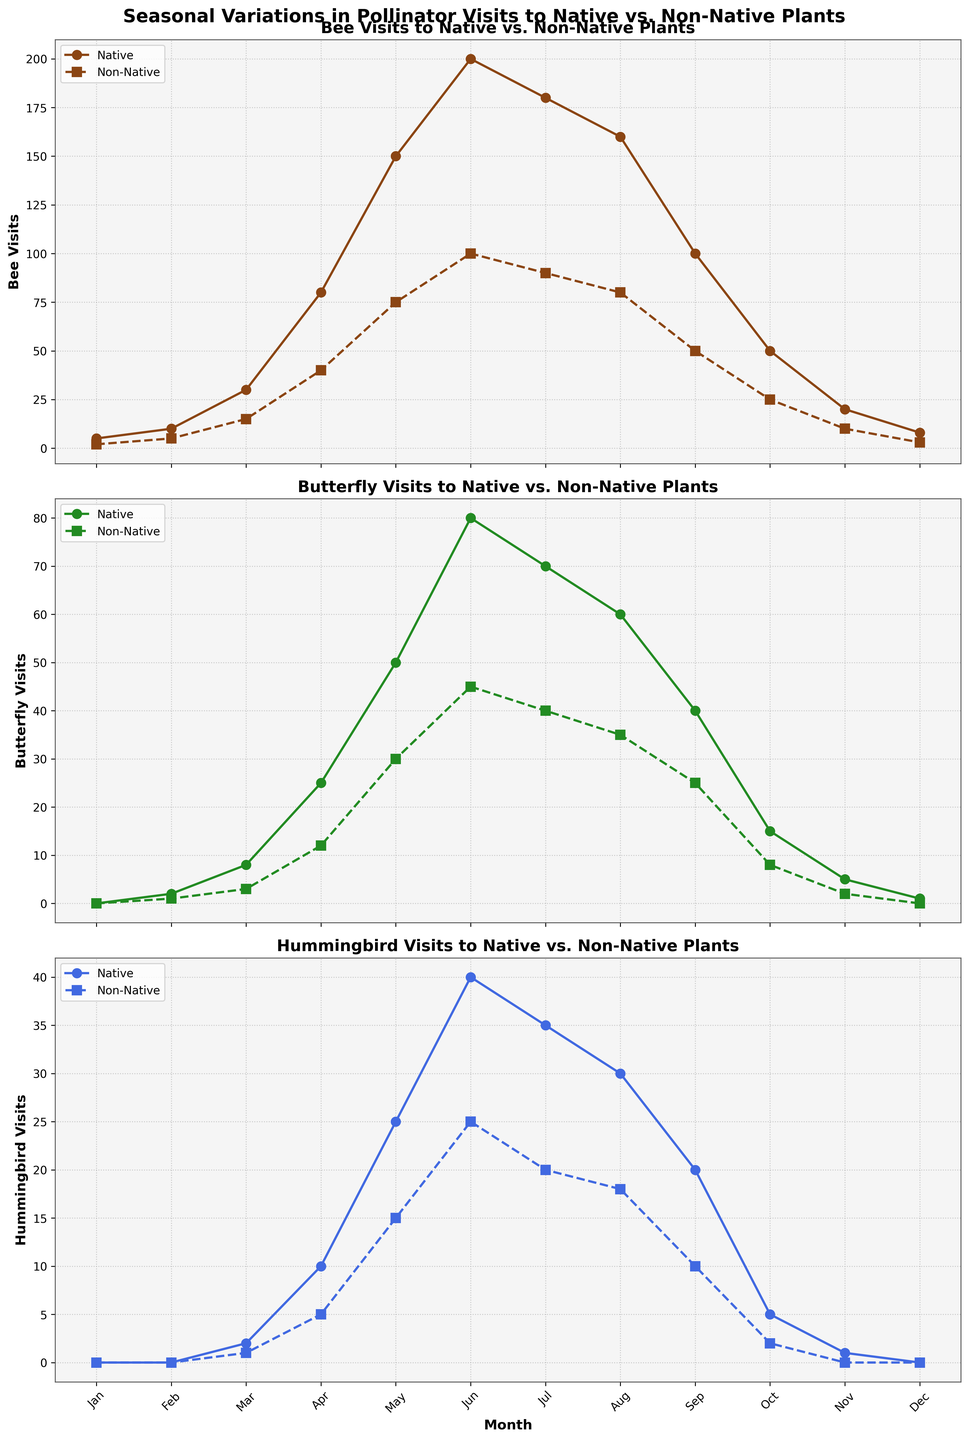Which month had the highest number of native bee visits? In the first subplot, observe the peak of the solid line representing native bee visits. It is highest in June.
Answer: June How many more visits did native plants receive from butterflies than hummingbirds in May? Comparing the middle and bottom subplots for May, native butterflies had 50 visits, and native hummingbirds had 25 visits. Calculating the difference, 50 - 25 = 25.
Answer: 25 During which month did non-native plants receive the same number of bee visits as butterfly visits? In the first and second subplots, look for a month where the dashed lines for bees and butterflies overlap. This occurs in February, with both having 5 bee and 5 butterfly visits.
Answer: February What is the average number of non-native hummingbird visits per month? Sum the monthly visits from the bottom subplot's dashed line: (0 + 0 + 1 + 5 + 15 + 25 + 20 + 18 + 10 + 2 + 0 + 0) = 96. Then divide by the number of months, 96/12 = 8.
Answer: 8 In which season do native plants see the largest relative increase in bee visits compared to non-native plants? Identify the period with the greatest disparity in the steepness of the solid vs. dashed lines in the first subplot. The largest relative increase happens in spring (March to May).
Answer: Spring Between native and non-native plants, which type received more butterfly visits in September, and by how much? In September, native butterflies had 40 visits and non-native had 25 visits. The difference is 40 - 25 = 15 visits.
Answer: Native, 15 Which pollinator showed the least variation in visits to non-native plants throughout the year? Compare the range of values across the dashed lines in all three subplots. Non-native hummingbirds have the least variation.
Answer: Hummingbird How does the pattern of native bee visits compare to native butterfly visits across the year? In the first and second subplots, notice native bee visits peak in June then decline, while butterfly visits also peak in June but with a gradual decline. Both increase towards spring and decrease in autumn.
Answer: Both peak in June What visual difference indicates the data trend for native versus non-native plant visits for each pollinator type? Observe the line styles: solid lines represent native plant visits, generally higher, while dashed lines represent non-native visits, consistently lower. The solid lines show more prominent peaks and trends.
Answer: Solid lines consistently higher 